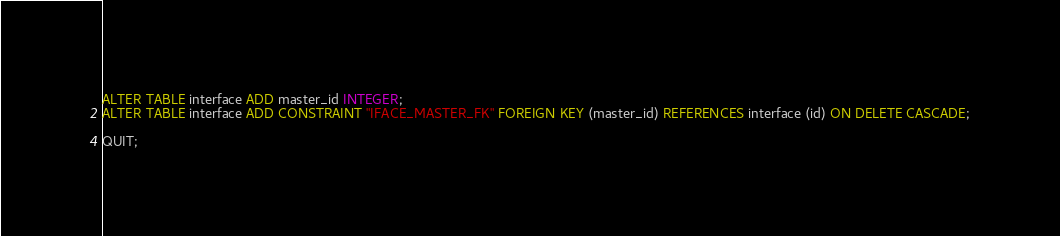Convert code to text. <code><loc_0><loc_0><loc_500><loc_500><_SQL_>ALTER TABLE interface ADD master_id INTEGER;
ALTER TABLE interface ADD CONSTRAINT "IFACE_MASTER_FK" FOREIGN KEY (master_id) REFERENCES interface (id) ON DELETE CASCADE;

QUIT;
</code> 